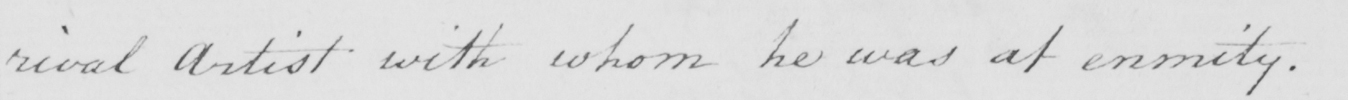Please transcribe the handwritten text in this image. rival Artist with whom he was at enmity . 